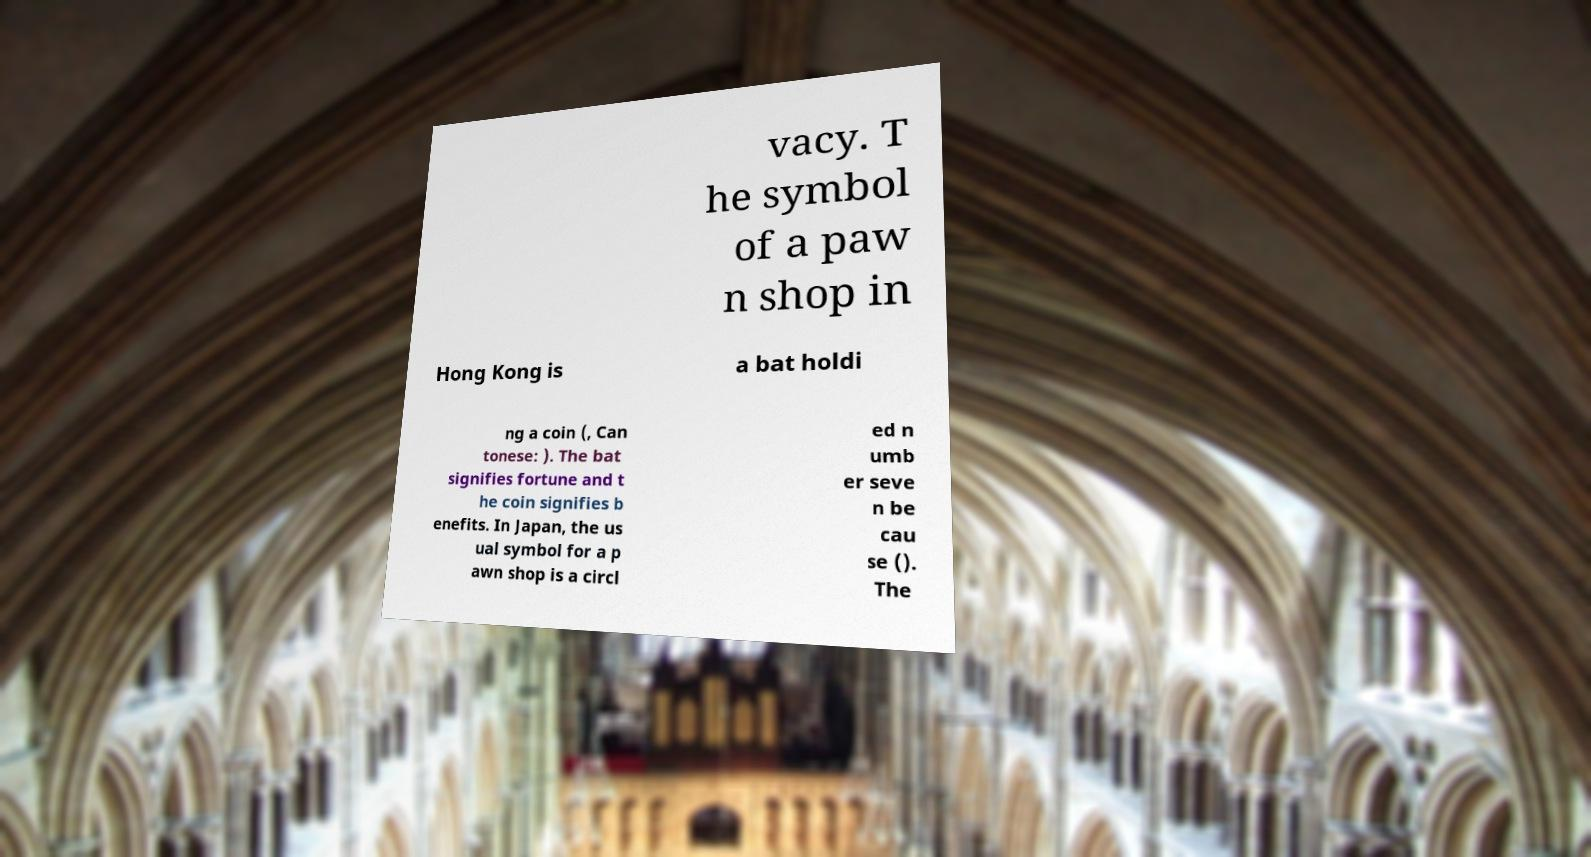For documentation purposes, I need the text within this image transcribed. Could you provide that? vacy. T he symbol of a paw n shop in Hong Kong is a bat holdi ng a coin (, Can tonese: ). The bat signifies fortune and t he coin signifies b enefits. In Japan, the us ual symbol for a p awn shop is a circl ed n umb er seve n be cau se (). The 